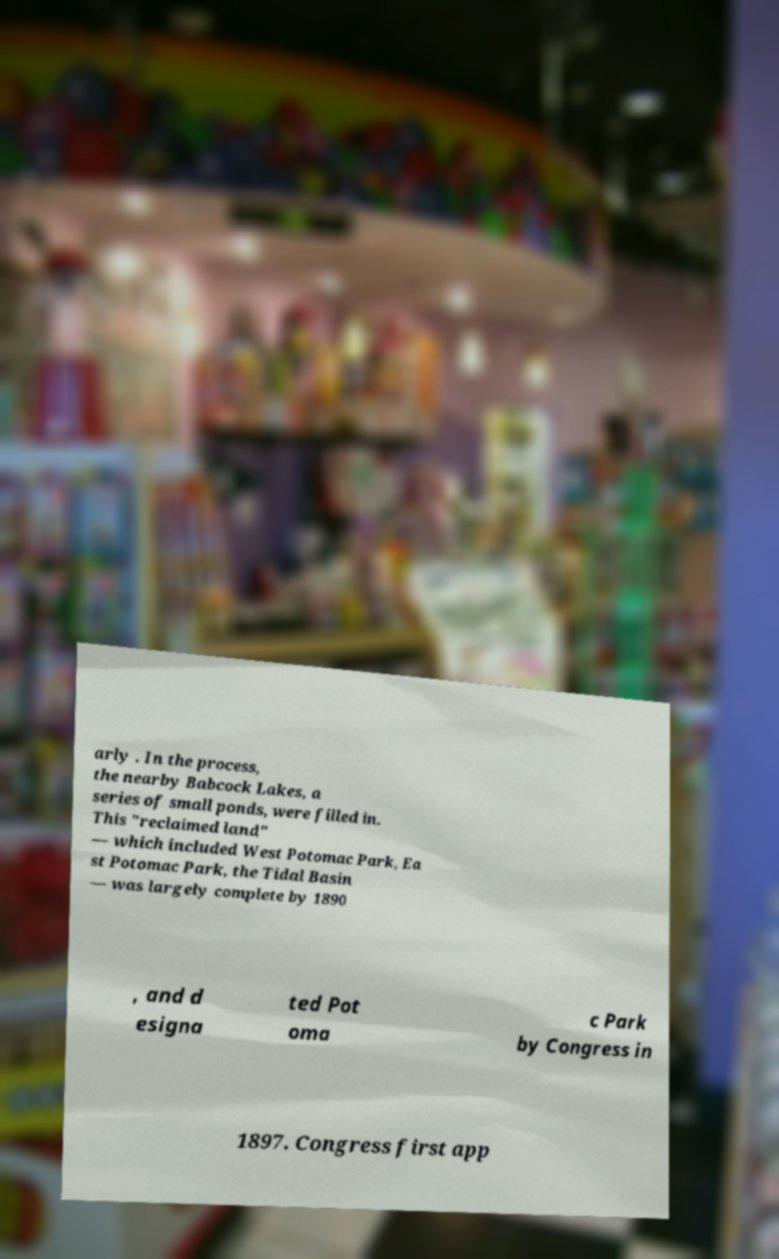Could you assist in decoding the text presented in this image and type it out clearly? arly . In the process, the nearby Babcock Lakes, a series of small ponds, were filled in. This "reclaimed land" — which included West Potomac Park, Ea st Potomac Park, the Tidal Basin — was largely complete by 1890 , and d esigna ted Pot oma c Park by Congress in 1897. Congress first app 